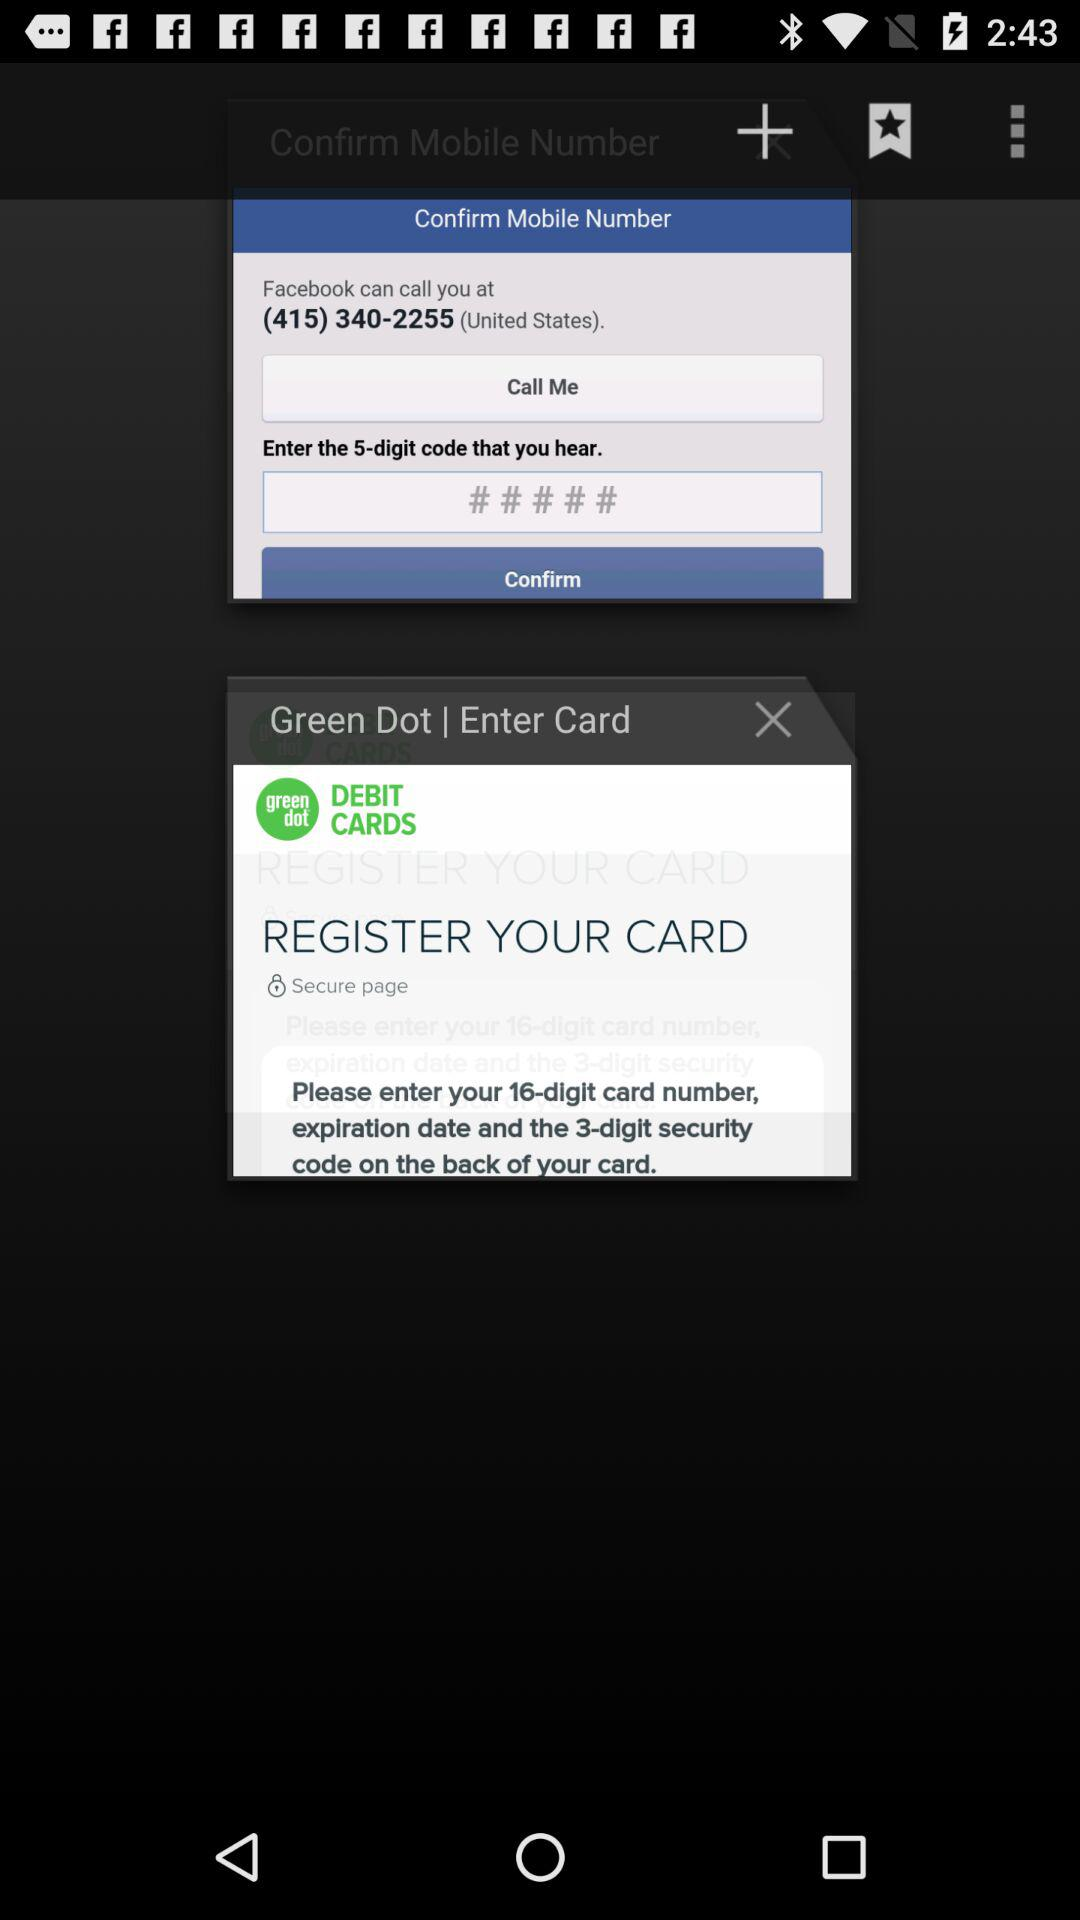What country is mentioned? The mentioned country is the United States. 